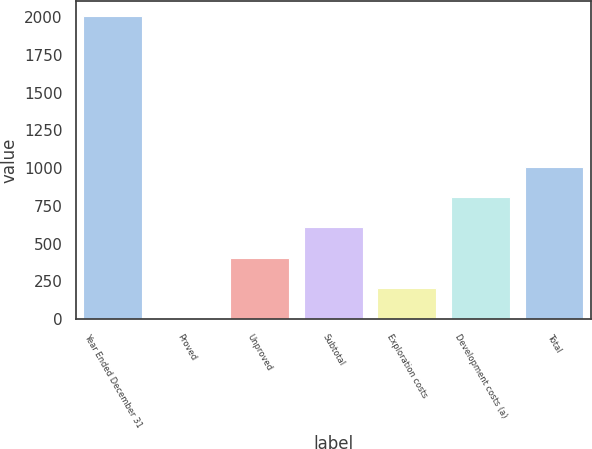Convert chart. <chart><loc_0><loc_0><loc_500><loc_500><bar_chart><fcel>Year Ended December 31<fcel>Proved<fcel>Unproved<fcel>Subtotal<fcel>Exploration costs<fcel>Development costs (a)<fcel>Total<nl><fcel>2008<fcel>8<fcel>408<fcel>608<fcel>208<fcel>808<fcel>1008<nl></chart> 